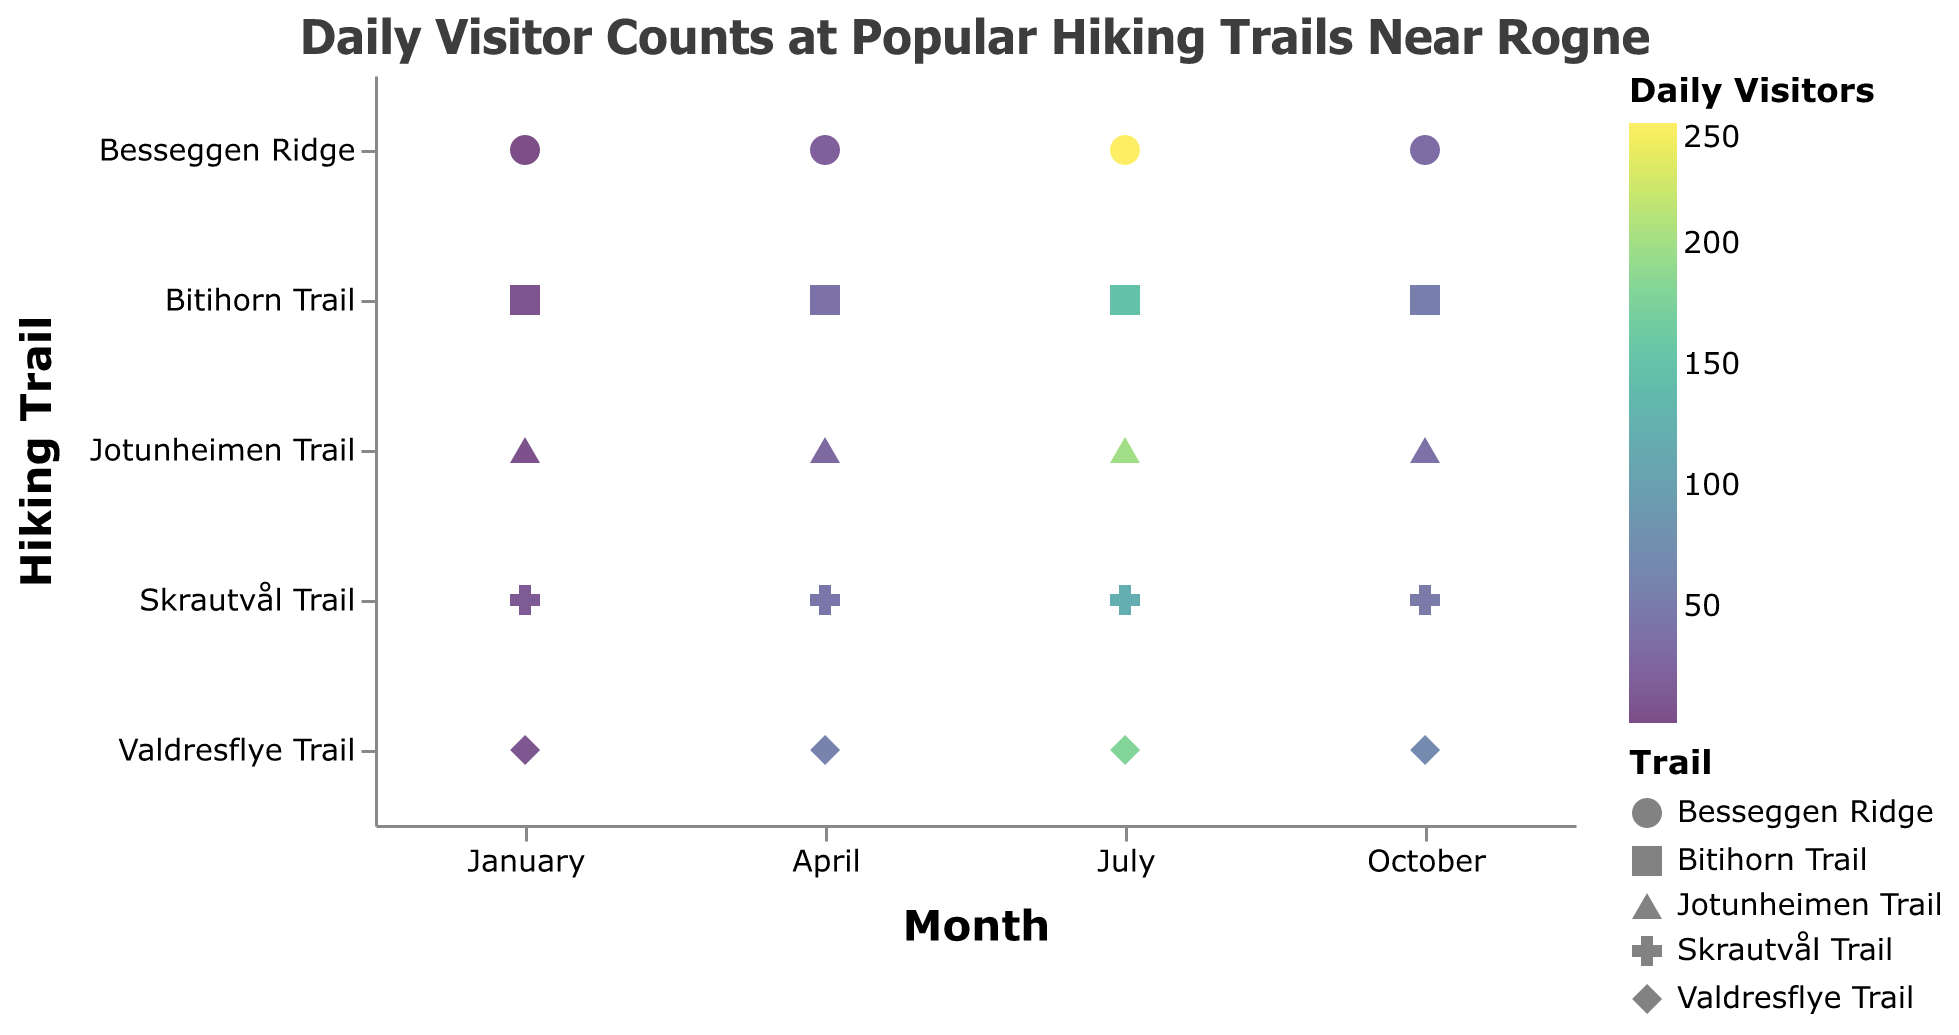What's the title of the figure? The title of the figure is usually mentioned at the top of the plot. In this case, it clearly states "Daily Visitor Counts at Popular Hiking Trails Near Rogne".
Answer: Daily Visitor Counts at Popular Hiking Trails Near Rogne Which month has the highest visitor count for Besseggen Ridge? From the strip plot, we can see that Besseggen Ridge has the highest visitor count in July, indicated by the data point with the highest color intensity.
Answer: July Which trail has the lowest number of visitors in January? By observing the points for each trail in January (the first cluster on the x-axis), Besseggen Ridge has the lowest number with just 2 daily visitors.
Answer: Besseggen Ridge What is the total number of visitors for Skrautvål Trail across all months? From the plot, we can note the visitor counts for Skrautvål Trail in different months: January (15), April (45), July (120), and October (50). Summing these up: 15 + 45 + 120 + 50 = 230.
Answer: 230 How does the visitor count for Valdresflye Trail in October compare to that in April? For Valdresflye Trail, the visitor count in October is 70, whereas it is 60 in April. So, the number in October is greater by 10.
Answer: October has 10 more visitors than April Which trail experiences the most significant increase in visitors from January to July? By comparing the visitor counts for each trail between January and July, Besseggen Ridge sees the most significant jump from 2 (January) to 250 (July), a difference of 248.
Answer: Besseggen Ridge Arrange the trails in ascending order of visitors in July. In July, the visitor counts are: Skrautvål Trail (120), Valdresflye Trail (180), Jotunheimen Trail (200), Besseggen Ridge (250), and Bitihorn Trail (150). Arranging these: Skrautvål Trail, Bitihorn Trail, Valdresflye Trail, Jotunheimen Trail, Besseggen Ridge.
Answer: Skrautvål Trail, Bitihorn Trail, Valdresflye Trail, Jotunheimen Trail, Besseggen Ridge Which month generally has the highest visitor counts across all trails? By observing the color density along the months, July shows the highest visitor counts for all trails, indicated by the darkest shades.
Answer: July Which trail sees the least variation in visitor counts throughout the year? By examining the color variations of the dots for each trail, Jotunheimen Trail shows the least variation with counts ranging from 5 to 200, a difference of 195. Other trails have larger variations.
Answer: Jotunheimen Trail 